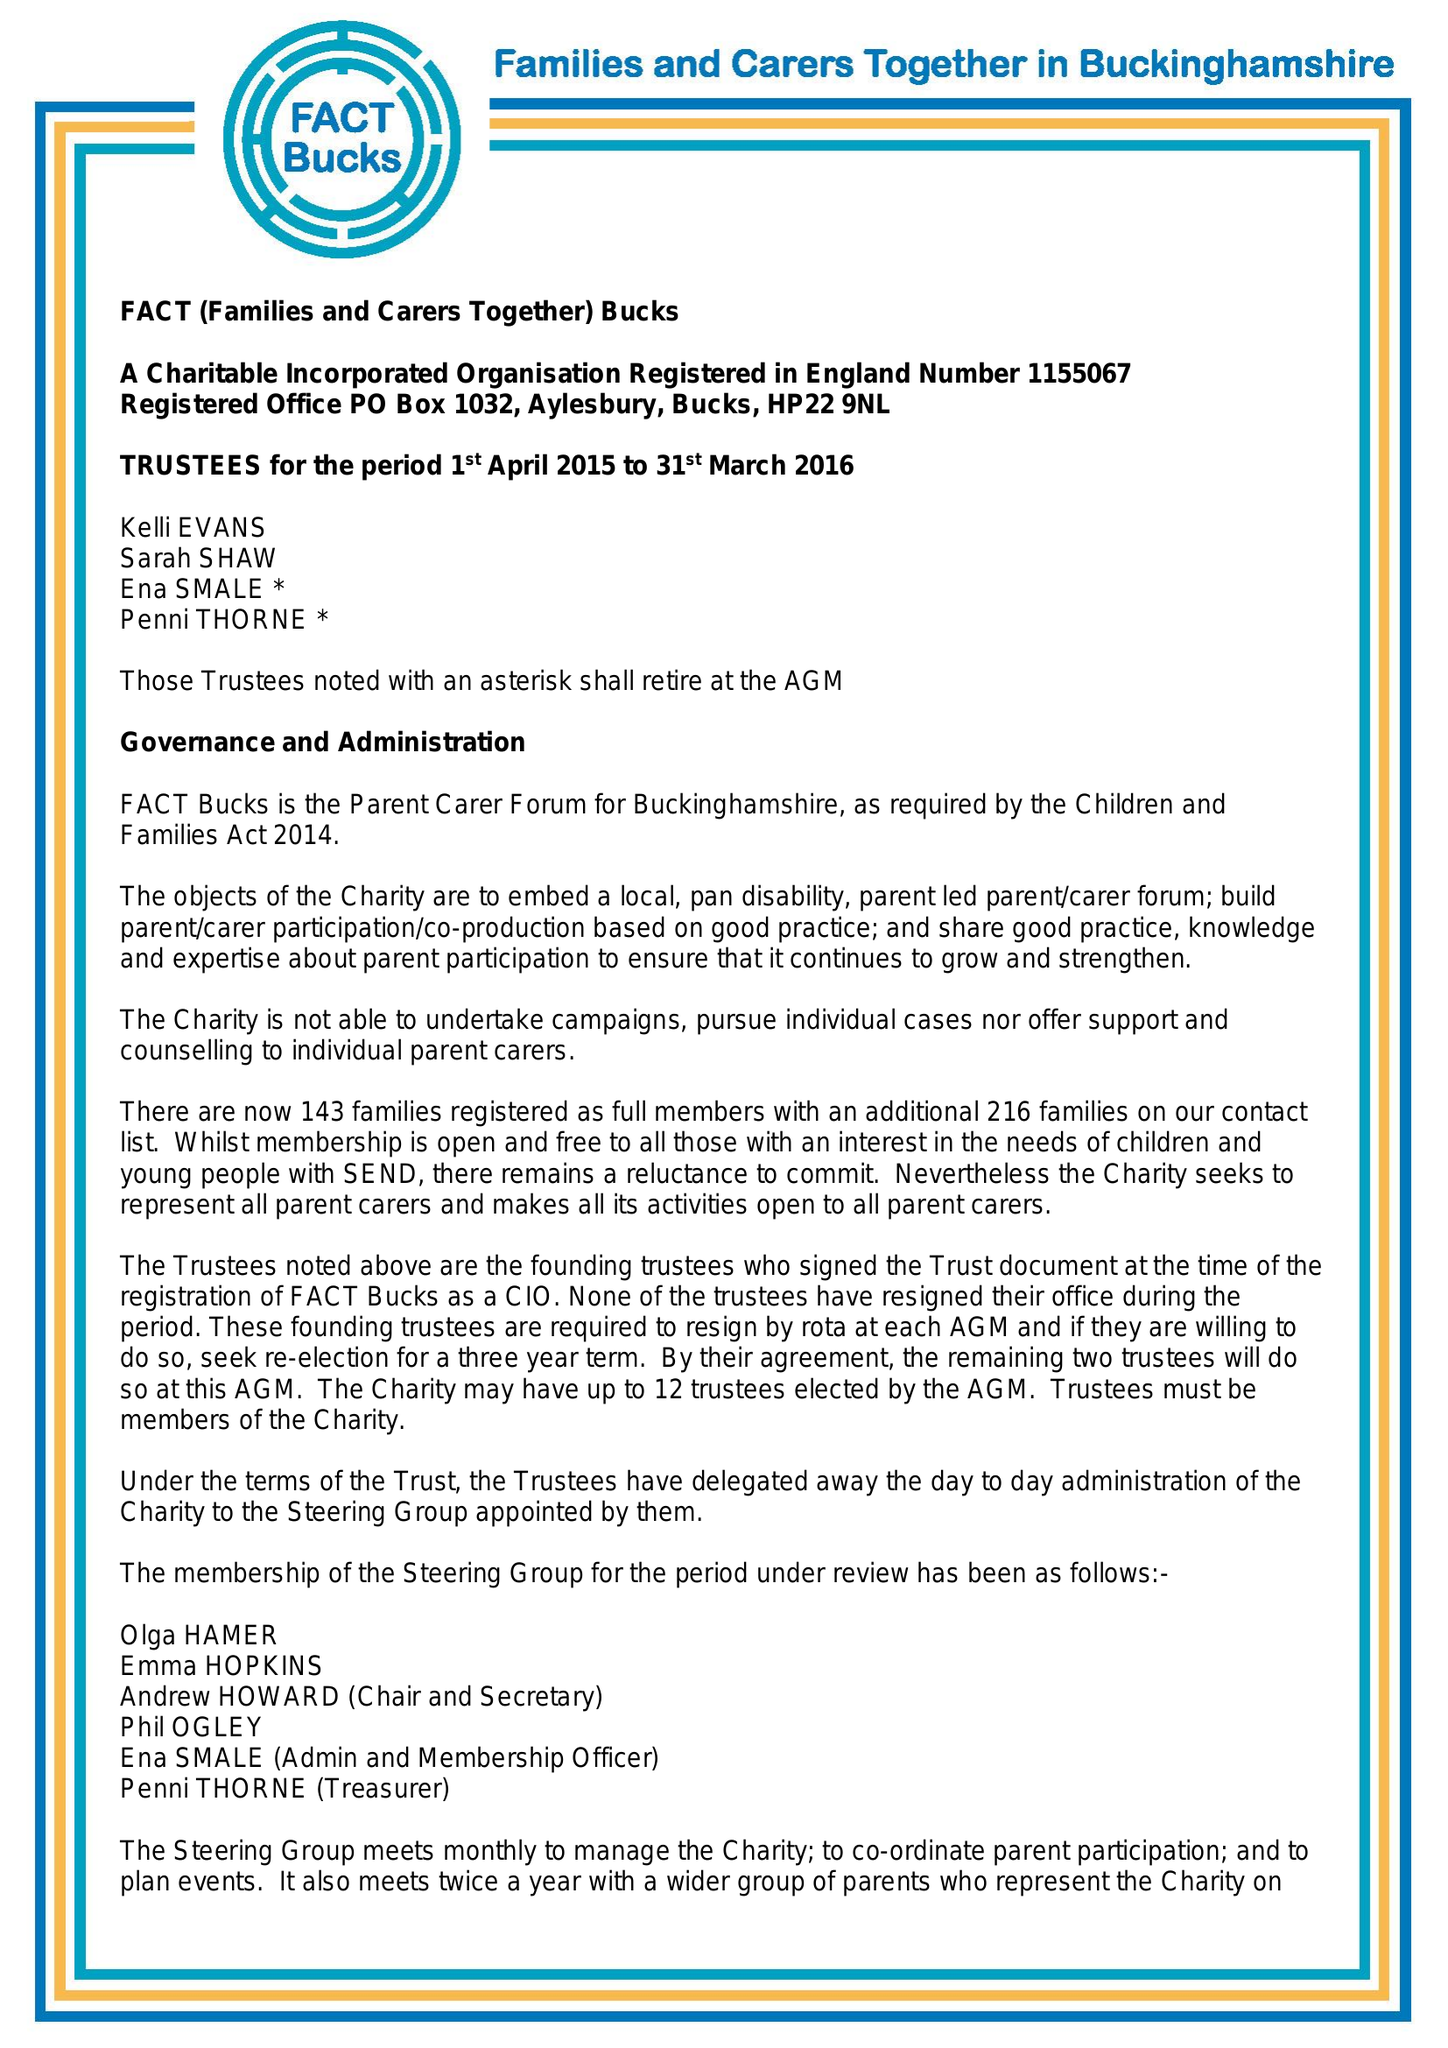What is the value for the address__street_line?
Answer the question using a single word or phrase. PO BOX 1032 